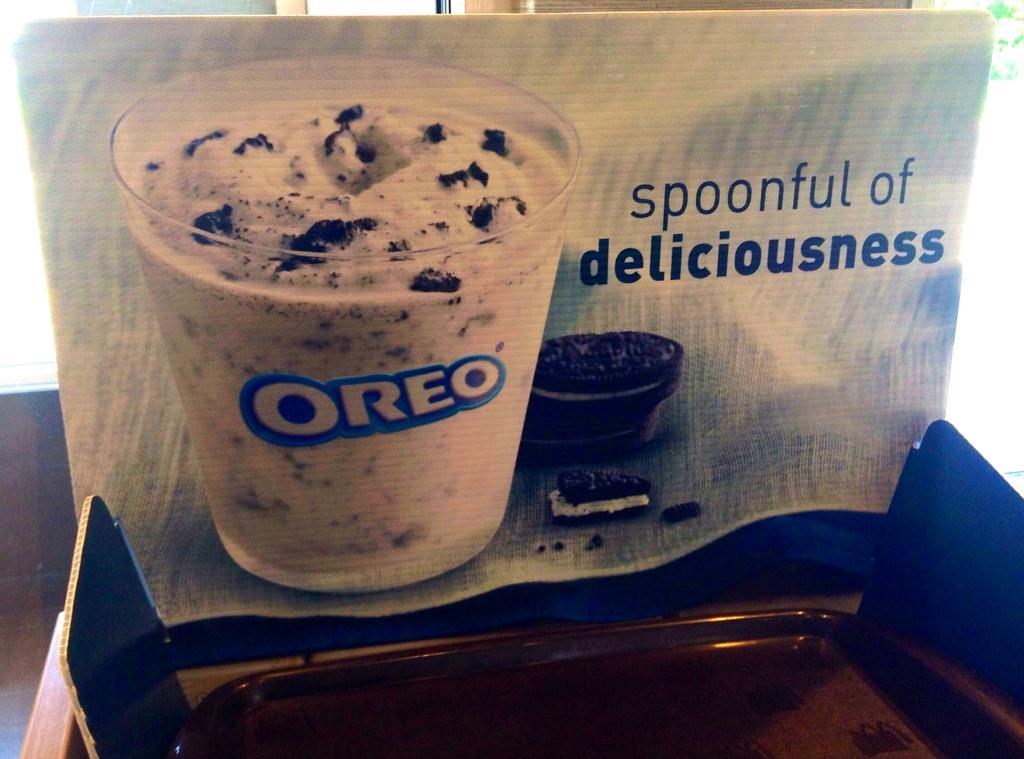Please provide a concise description of this image. In the picture we can see a card on with an advertisement on it of Oreo with a glass of cream and beside it, we can see some biscuits and written on it as a spoonful of deliciousness. 